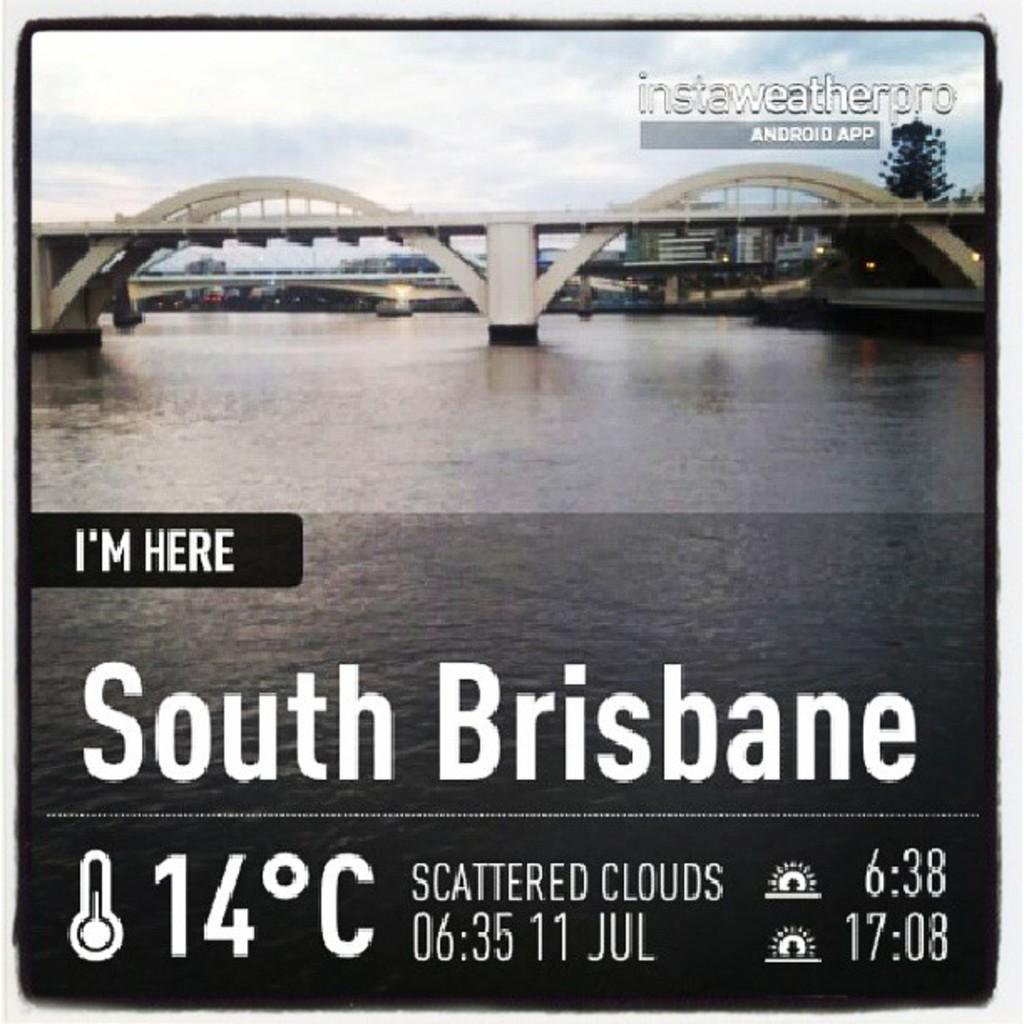<image>
Share a concise interpretation of the image provided. A weather report for South Brisbane showing 14 degrees. 